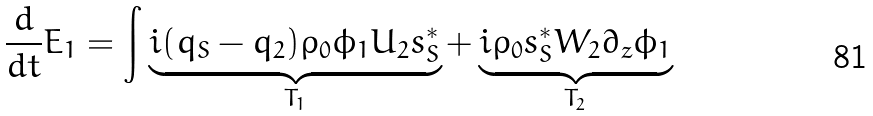Convert formula to latex. <formula><loc_0><loc_0><loc_500><loc_500>\frac { d } { d t } E _ { 1 } = \int \underbrace { i ( q _ { S } - q _ { 2 } ) \rho _ { 0 } \phi _ { 1 } U _ { 2 } s _ { S } ^ { * } } _ { T _ { 1 } } + \underbrace { i \rho _ { 0 } s _ { S } ^ { * } W _ { 2 } \partial _ { z } \phi _ { 1 } } _ { T _ { 2 } }</formula> 